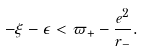<formula> <loc_0><loc_0><loc_500><loc_500>- \xi - \epsilon < \varpi _ { + } - \frac { e ^ { 2 } } { r _ { - } } .</formula> 